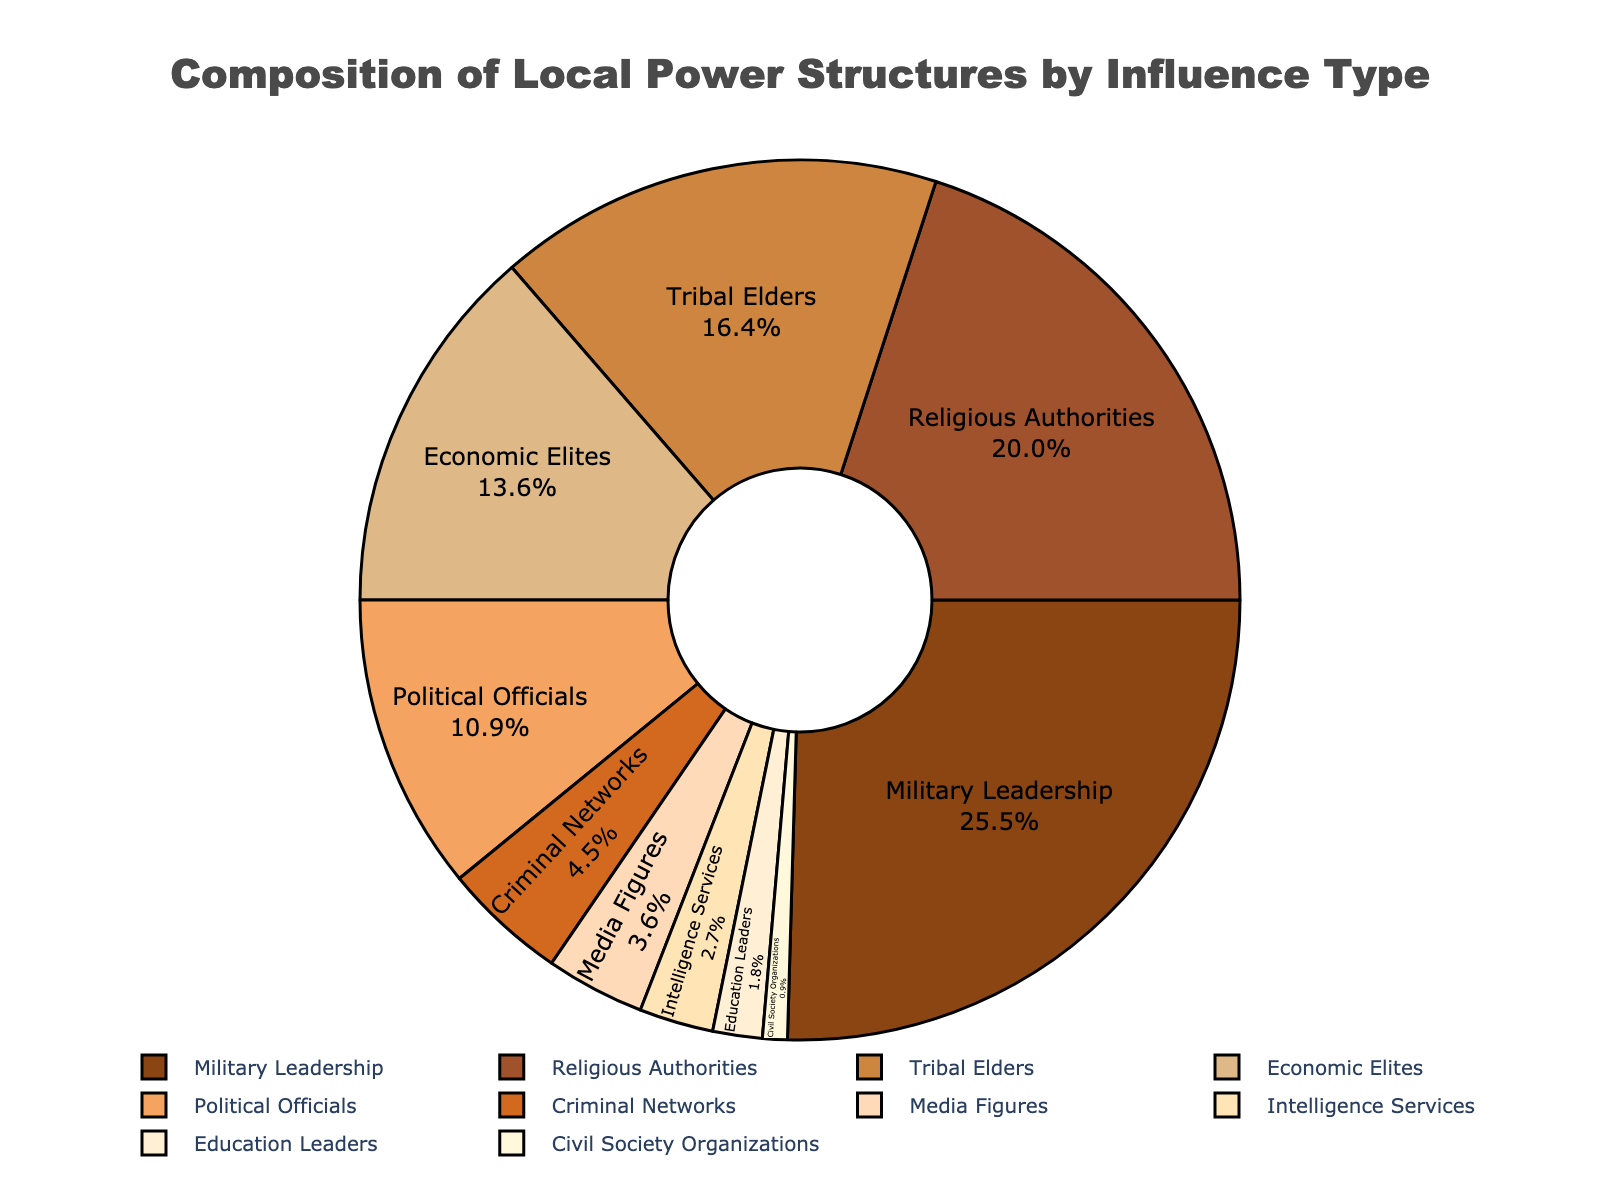what is the combined influence percentage of Military Leadership and Religious Authorities? Add the influence percentages of Military Leadership (28%) and Religious Authorities (22%). 28 + 22 = 50
Answer: 50% Which power structure has the least influence? Look for the smallest value on the chart. Civil Society Organizations has the smallest influence percentage at 1%.
Answer: Civil Society Organizations How many power structures have an influence percentage greater than 15? Count the number of power structures listed on the chart that have influence percentages above 15%. Military Leadership (28%), Religious Authorities (22%), and Tribal Elders (18%) are greater than 15%. There are 3 power structures in total.
Answer: 3 Do Military Leadership and Political Officials combined have more influence than Religious Authorities? Compare the combined percentages of Military Leadership (28%) and Political Officials (12%) with the percentage of Religious Authorities (22%). 28 + 12 = 40, which is greater than 22.
Answer: Yes Which power structure is represented by the darkest brown color on the chart? Identify the darkest brown section on the pie chart. The darkest brown represents Military Leadership.
Answer: Military Leadership By what percentage do Media Figures' influence exceed that of Intelligence Services? Subtract the influence percentage of Intelligence Services (3%) from Media Figures' percentage (4%). 4 - 3 = 1
Answer: 1% What is the total influence percentage of groups with less than 5% influence? Add the influence percentages of Criminal Networks (5%), Media Figures (4%), Intelligence Services (3%), Education Leaders (2%), and Civil Society Organizations (1%). 5 + 4 + 3 + 2 + 1 = 15
Answer: 15% How does the influence of Political Officials compare to that of Economic Elites? Compare the percentages: Political Officials have 12% and Economic Elites have 15%. Political Officials have 3% less influence.
Answer: 3% less Which has a larger influence percentage: Economic Elites or Tribal Elders? Compare the percentages: Economic Elites have 15% and Tribal Elders have 18%. Tribal Elders have a larger influence percentage.
Answer: Tribal Elders What is the average influence percentage of Tribal Elders, Economic Elites, and Political Officials? Add their percentages and divide by the number of structures. (18+15+12) / 3 = 45 / 3 = 15
Answer: 15% 